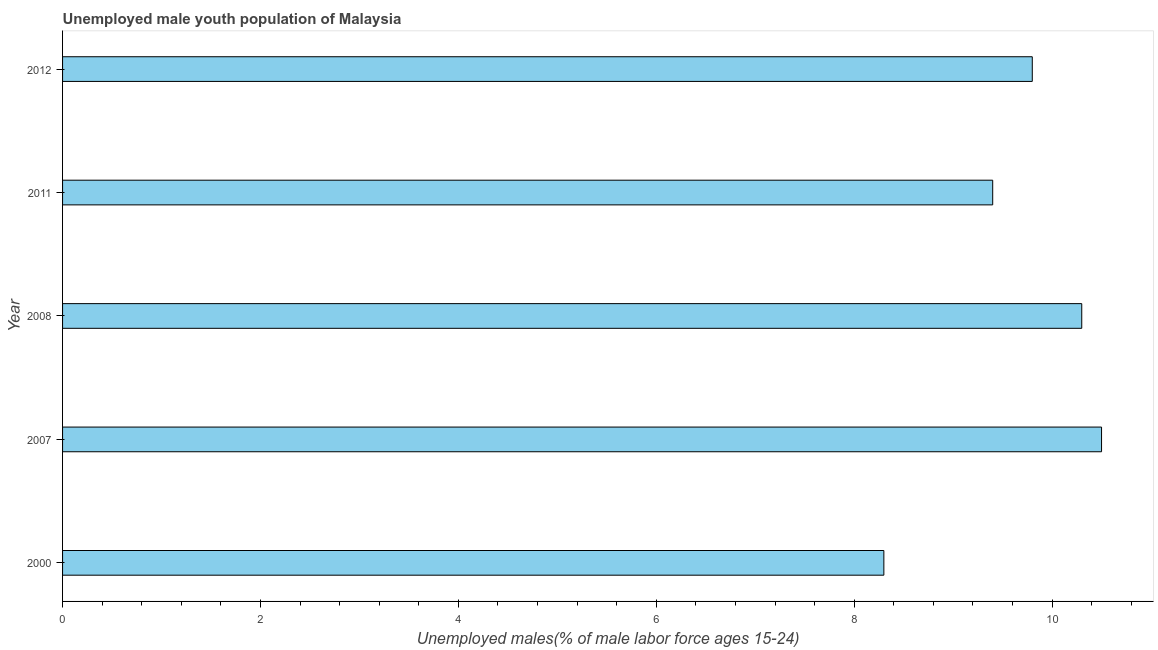Does the graph contain any zero values?
Offer a very short reply. No. What is the title of the graph?
Provide a short and direct response. Unemployed male youth population of Malaysia. What is the label or title of the X-axis?
Provide a short and direct response. Unemployed males(% of male labor force ages 15-24). What is the unemployed male youth in 2011?
Offer a very short reply. 9.4. Across all years, what is the maximum unemployed male youth?
Give a very brief answer. 10.5. Across all years, what is the minimum unemployed male youth?
Ensure brevity in your answer.  8.3. In which year was the unemployed male youth maximum?
Offer a terse response. 2007. What is the sum of the unemployed male youth?
Offer a terse response. 48.3. What is the difference between the unemployed male youth in 2000 and 2007?
Ensure brevity in your answer.  -2.2. What is the average unemployed male youth per year?
Keep it short and to the point. 9.66. What is the median unemployed male youth?
Offer a very short reply. 9.8. In how many years, is the unemployed male youth greater than 6.4 %?
Provide a short and direct response. 5. Do a majority of the years between 2011 and 2007 (inclusive) have unemployed male youth greater than 8.4 %?
Keep it short and to the point. Yes. What is the ratio of the unemployed male youth in 2000 to that in 2008?
Provide a short and direct response. 0.81. Is the unemployed male youth in 2007 less than that in 2011?
Make the answer very short. No. Is the difference between the unemployed male youth in 2000 and 2011 greater than the difference between any two years?
Make the answer very short. No. What is the difference between the highest and the lowest unemployed male youth?
Keep it short and to the point. 2.2. In how many years, is the unemployed male youth greater than the average unemployed male youth taken over all years?
Offer a terse response. 3. Are all the bars in the graph horizontal?
Offer a very short reply. Yes. What is the difference between two consecutive major ticks on the X-axis?
Give a very brief answer. 2. What is the Unemployed males(% of male labor force ages 15-24) in 2000?
Ensure brevity in your answer.  8.3. What is the Unemployed males(% of male labor force ages 15-24) in 2008?
Give a very brief answer. 10.3. What is the Unemployed males(% of male labor force ages 15-24) of 2011?
Ensure brevity in your answer.  9.4. What is the Unemployed males(% of male labor force ages 15-24) in 2012?
Keep it short and to the point. 9.8. What is the difference between the Unemployed males(% of male labor force ages 15-24) in 2000 and 2007?
Give a very brief answer. -2.2. What is the difference between the Unemployed males(% of male labor force ages 15-24) in 2000 and 2008?
Your response must be concise. -2. What is the difference between the Unemployed males(% of male labor force ages 15-24) in 2000 and 2012?
Offer a very short reply. -1.5. What is the difference between the Unemployed males(% of male labor force ages 15-24) in 2008 and 2011?
Make the answer very short. 0.9. What is the ratio of the Unemployed males(% of male labor force ages 15-24) in 2000 to that in 2007?
Offer a terse response. 0.79. What is the ratio of the Unemployed males(% of male labor force ages 15-24) in 2000 to that in 2008?
Offer a very short reply. 0.81. What is the ratio of the Unemployed males(% of male labor force ages 15-24) in 2000 to that in 2011?
Ensure brevity in your answer.  0.88. What is the ratio of the Unemployed males(% of male labor force ages 15-24) in 2000 to that in 2012?
Provide a succinct answer. 0.85. What is the ratio of the Unemployed males(% of male labor force ages 15-24) in 2007 to that in 2008?
Keep it short and to the point. 1.02. What is the ratio of the Unemployed males(% of male labor force ages 15-24) in 2007 to that in 2011?
Your answer should be compact. 1.12. What is the ratio of the Unemployed males(% of male labor force ages 15-24) in 2007 to that in 2012?
Offer a very short reply. 1.07. What is the ratio of the Unemployed males(% of male labor force ages 15-24) in 2008 to that in 2011?
Offer a terse response. 1.1. What is the ratio of the Unemployed males(% of male labor force ages 15-24) in 2008 to that in 2012?
Ensure brevity in your answer.  1.05. 